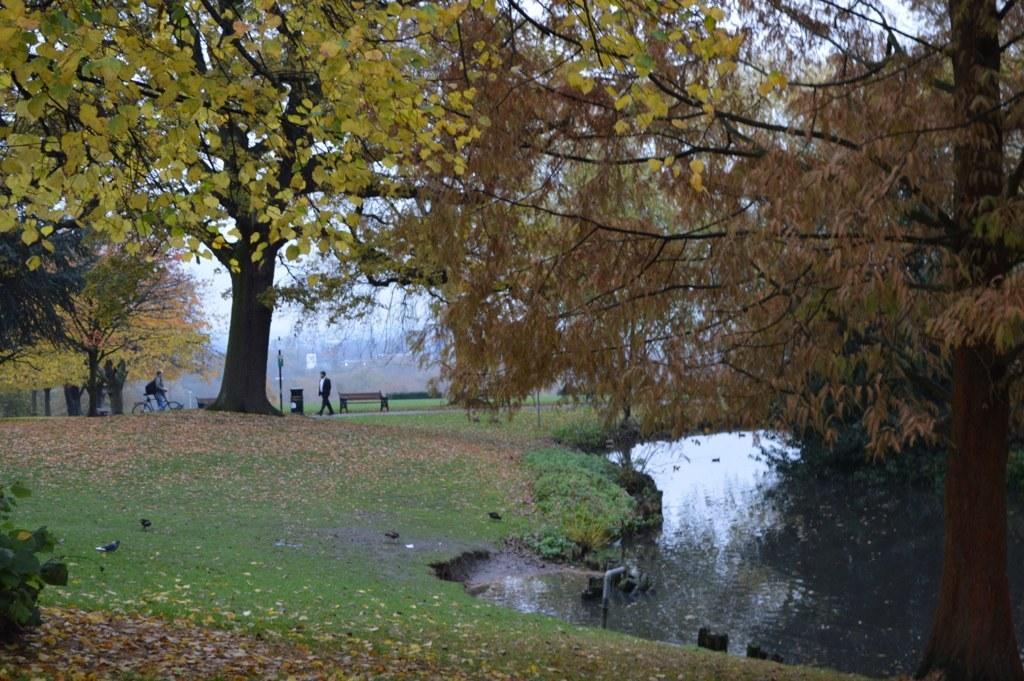Can you describe this image briefly? In the given picture , I can a small lake and also i can see a garden after we can see people one is riding on cycle and other person is walking and also i can see a electrical pole after that there is a dust bin and also two chairs which are available in the garden , They are certain trees. 